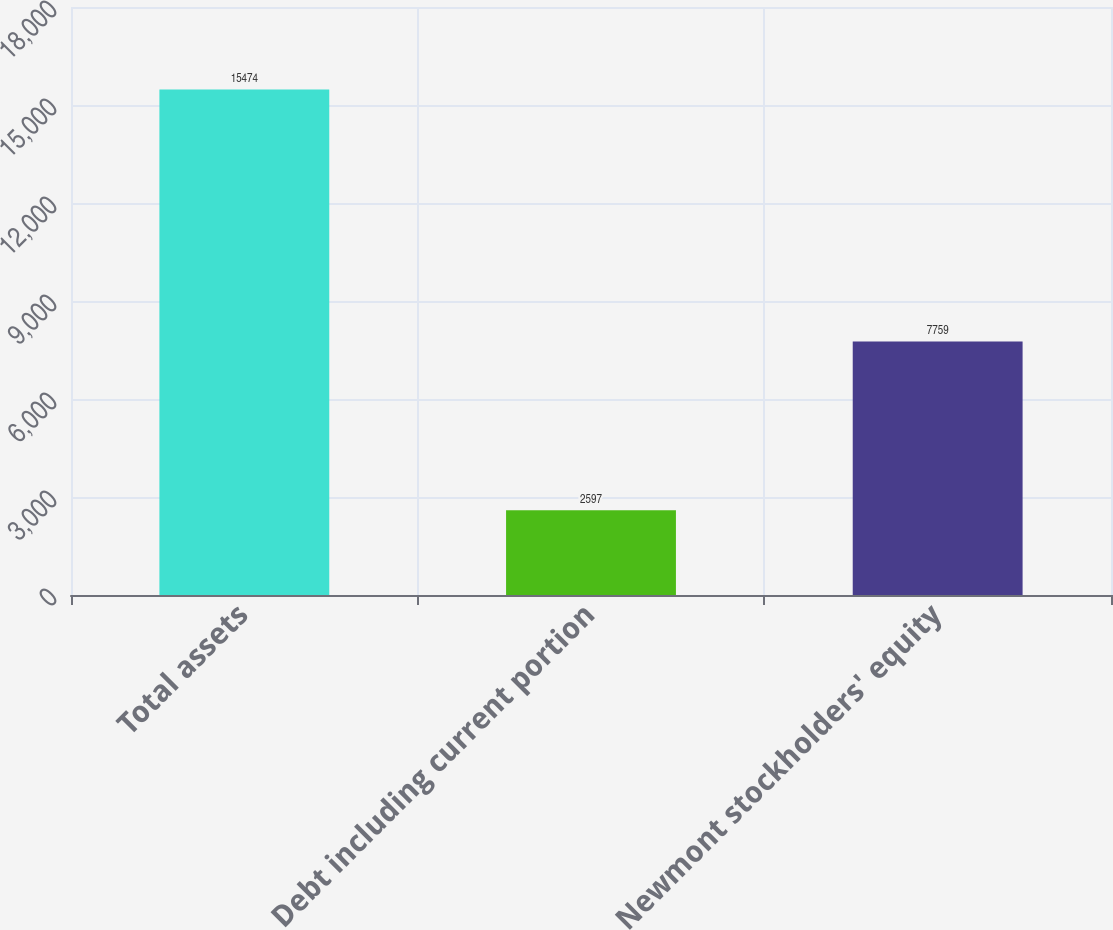<chart> <loc_0><loc_0><loc_500><loc_500><bar_chart><fcel>Total assets<fcel>Debt including current portion<fcel>Newmont stockholders' equity<nl><fcel>15474<fcel>2597<fcel>7759<nl></chart> 